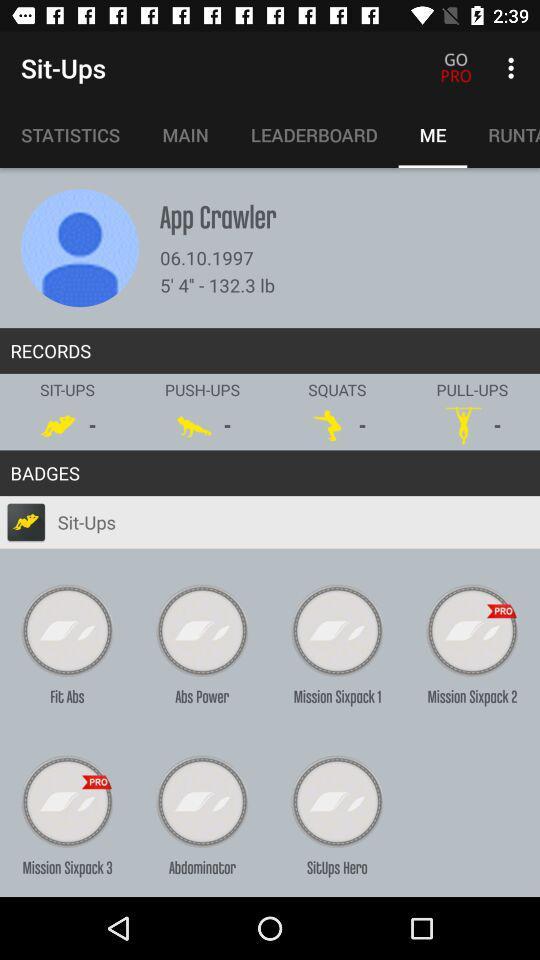What is the height of the user? The height of the user is 5 feet 4 inches. 